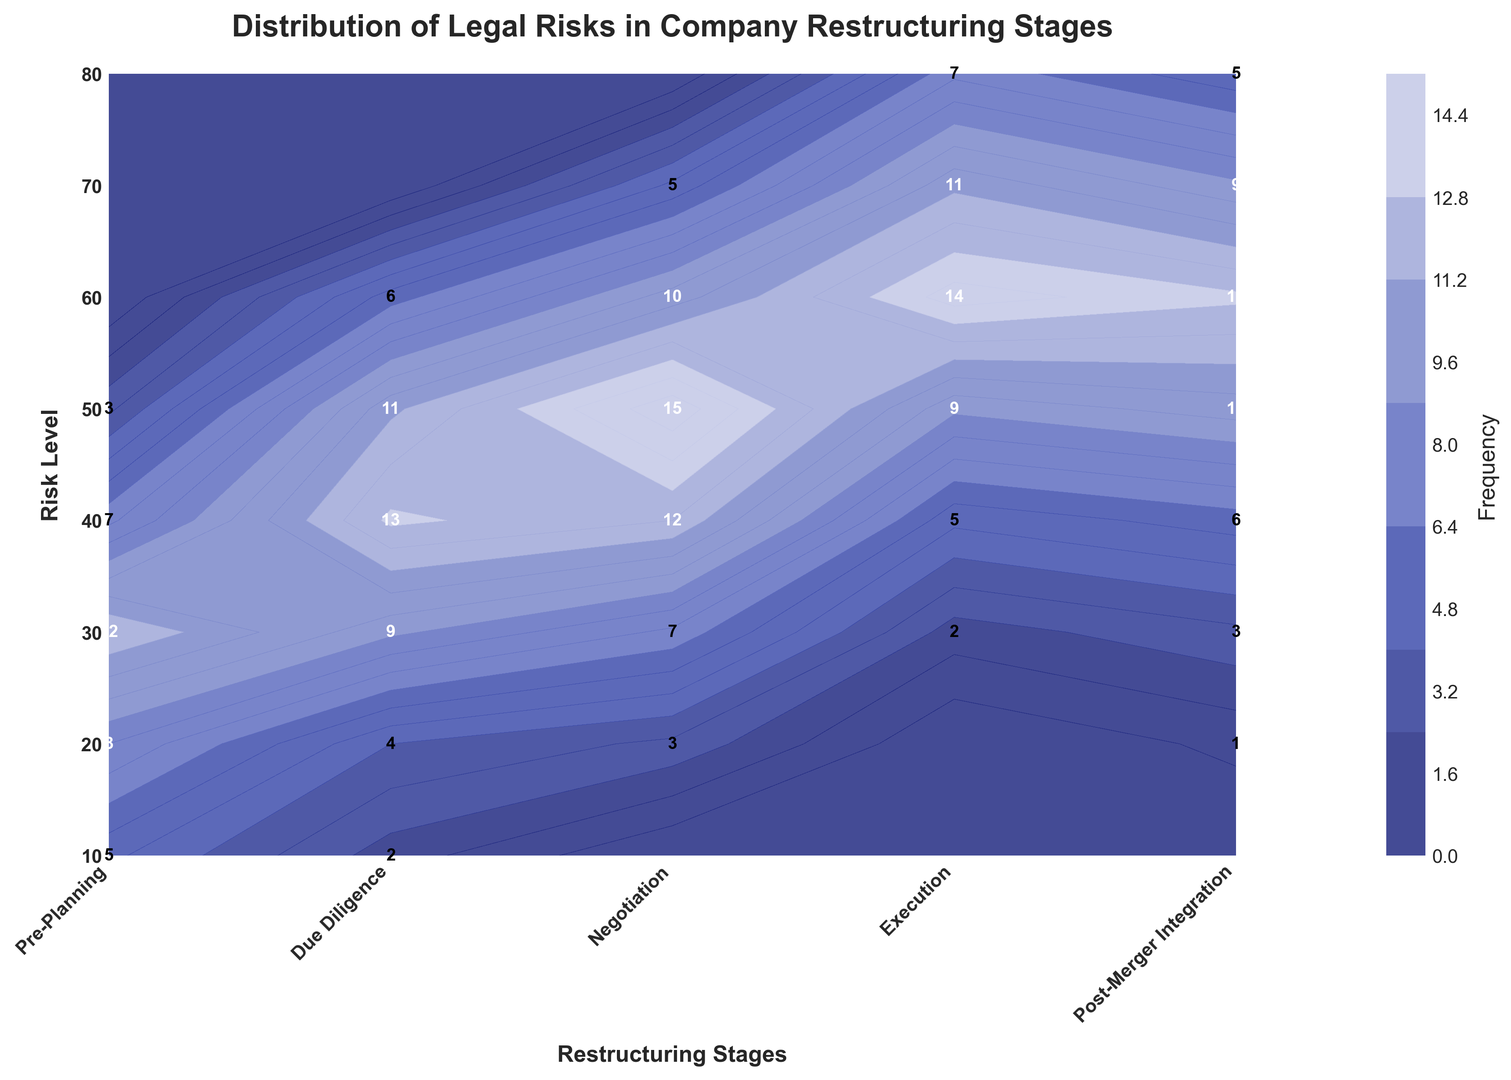Which stage has the highest frequency for the highest risk level? By observing the highest risk level (80) on the y-axis and looking at the stages on the x-axis, the Execution stage has the highest frequency of 7 for the higher risk levels.
Answer: Execution What is the most frequent risk level during the Negotiation stage? Observe the frequency values for the Negotiation stage and identify the risk level with the highest frequency. The highest frequency during this stage is 15, corresponding to a risk level of 50.
Answer: 50 How does the distribution of risk levels differ between Pre-Planning and Execution stages? Compare the frequencies of each risk level for Pre-Planning and Execution stages by examining the contour plot. Pre-Planning has lower frequencies across risk levels, whereas Execution has higher frequencies, particularly from risk levels 50 to 80.
Answer: Pre-Planning: lower frequencies, Execution: higher frequencies At which stage does the risk level of 30 experience the highest frequency? By checking the frequency values for the risk level of 30 across all stages, the Due Diligence stage has the highest frequency of 9 for risk level 30.
Answer: Due Diligence What is the combined frequency of risk levels 40 and 50 during the Post-Merger Integration stage? Sum the frequencies for risk levels 40 (6) and 50 (10) during the Post-Merger Integration stage: 6 + 10 = 16.
Answer: 16 Which stage exhibits the lowest frequency for risk level 10? Looking at the frequencies for risk level 10 across all stages, Due Diligence has the lowest frequency with a value of 2.
Answer: Due Diligence Does the frequency of risk level 40 increase or decrease as the stages progress from Pre-Planning to Execution? Track the frequency values for risk level 40 from Pre-Planning to Execution. The frequencies show an increasing trend from 7 in Pre-Planning to 14 in Execution.
Answer: Increase How many stages have a frequency greater than 10 for risk level 60? Count the number of stages where the frequency for risk level 60 exceeds 10. There are two stages: Execution (14) and Post-Merger Integration (13).
Answer: Two Between which stages does the frequency of risk level 20 change the most? Calculate the differences in frequency for risk level 20 between consecutive stages. The highest change is seen between Pre-Planning (8) and Due Diligence (4), with a difference of 4.
Answer: Pre-Planning and Due Diligence 